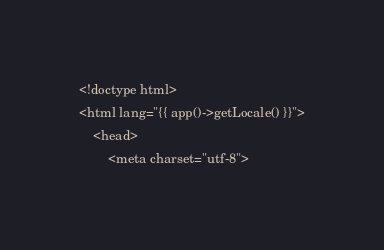<code> <loc_0><loc_0><loc_500><loc_500><_PHP_><!doctype html>
<html lang="{{ app()->getLocale() }}">
    <head>
        <meta charset="utf-8"></code> 